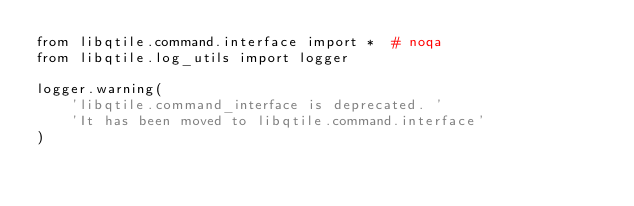<code> <loc_0><loc_0><loc_500><loc_500><_Python_>from libqtile.command.interface import *  # noqa
from libqtile.log_utils import logger

logger.warning(
    'libqtile.command_interface is deprecated. '
    'It has been moved to libqtile.command.interface'
)
</code> 